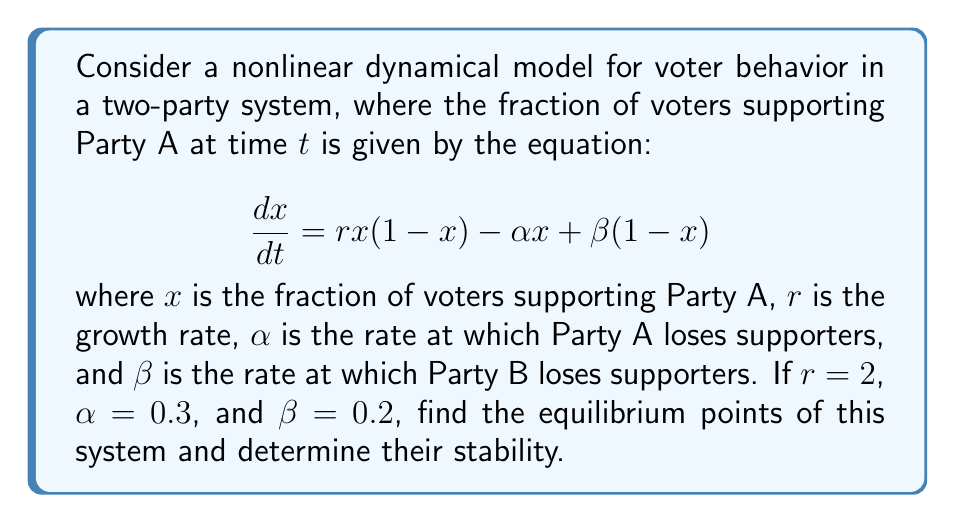Can you solve this math problem? 1. To find the equilibrium points, we set $\frac{dx}{dt} = 0$:

   $$rx(1-x) - \alpha x + \beta(1-x) = 0$$

2. Substitute the given values:

   $$2x(1-x) - 0.3x + 0.2(1-x) = 0$$

3. Expand the equation:

   $$2x - 2x^2 - 0.3x + 0.2 - 0.2x = 0$$

4. Simplify:

   $$-2x^2 + 1.5x + 0.2 = 0$$

5. This is a quadratic equation. We can solve it using the quadratic formula:

   $$x = \frac{-b \pm \sqrt{b^2 - 4ac}}{2a}$$

   where $a=-2$, $b=1.5$, and $c=0.2$

6. Plugging in these values:

   $$x = \frac{-1.5 \pm \sqrt{1.5^2 - 4(-2)(0.2)}}{2(-2)}$$

7. Simplify:

   $$x = \frac{-1.5 \pm \sqrt{2.25 + 1.6}}{-4} = \frac{-1.5 \pm \sqrt{3.85}}{-4}$$

8. Calculate the equilibrium points:

   $$x_1 \approx 0.8098, x_2 \approx 0.1902$$

9. To determine stability, we calculate $\frac{d}{dx}(\frac{dx}{dt})$ at each equilibrium point:

   $$\frac{d}{dx}(\frac{dx}{dt}) = r(1-2x) - \alpha - \beta$$

10. Substitute $r=2$, $\alpha=0.3$, and $\beta=0.2$:

    $$\frac{d}{dx}(\frac{dx}{dt}) = 2(1-2x) - 0.5$$

11. Evaluate at $x_1 \approx 0.8098$:

    $$\frac{d}{dx}(\frac{dx}{dt})|_{x_1} \approx 2(1-2(0.8098)) - 0.5 \approx -1.6196$$

12. Evaluate at $x_2 \approx 0.1902$:

    $$\frac{d}{dx}(\frac{dx}{dt})|_{x_2} \approx 2(1-2(0.1902)) - 0.5 \approx 1.6196$$

13. Since $\frac{d}{dx}(\frac{dx}{dt})|_{x_1} < 0$, $x_1$ is stable.
    Since $\frac{d}{dx}(\frac{dx}{dt})|_{x_2} > 0$, $x_2$ is unstable.
Answer: Equilibrium points: $x_1 \approx 0.8098$ (stable), $x_2 \approx 0.1902$ (unstable) 